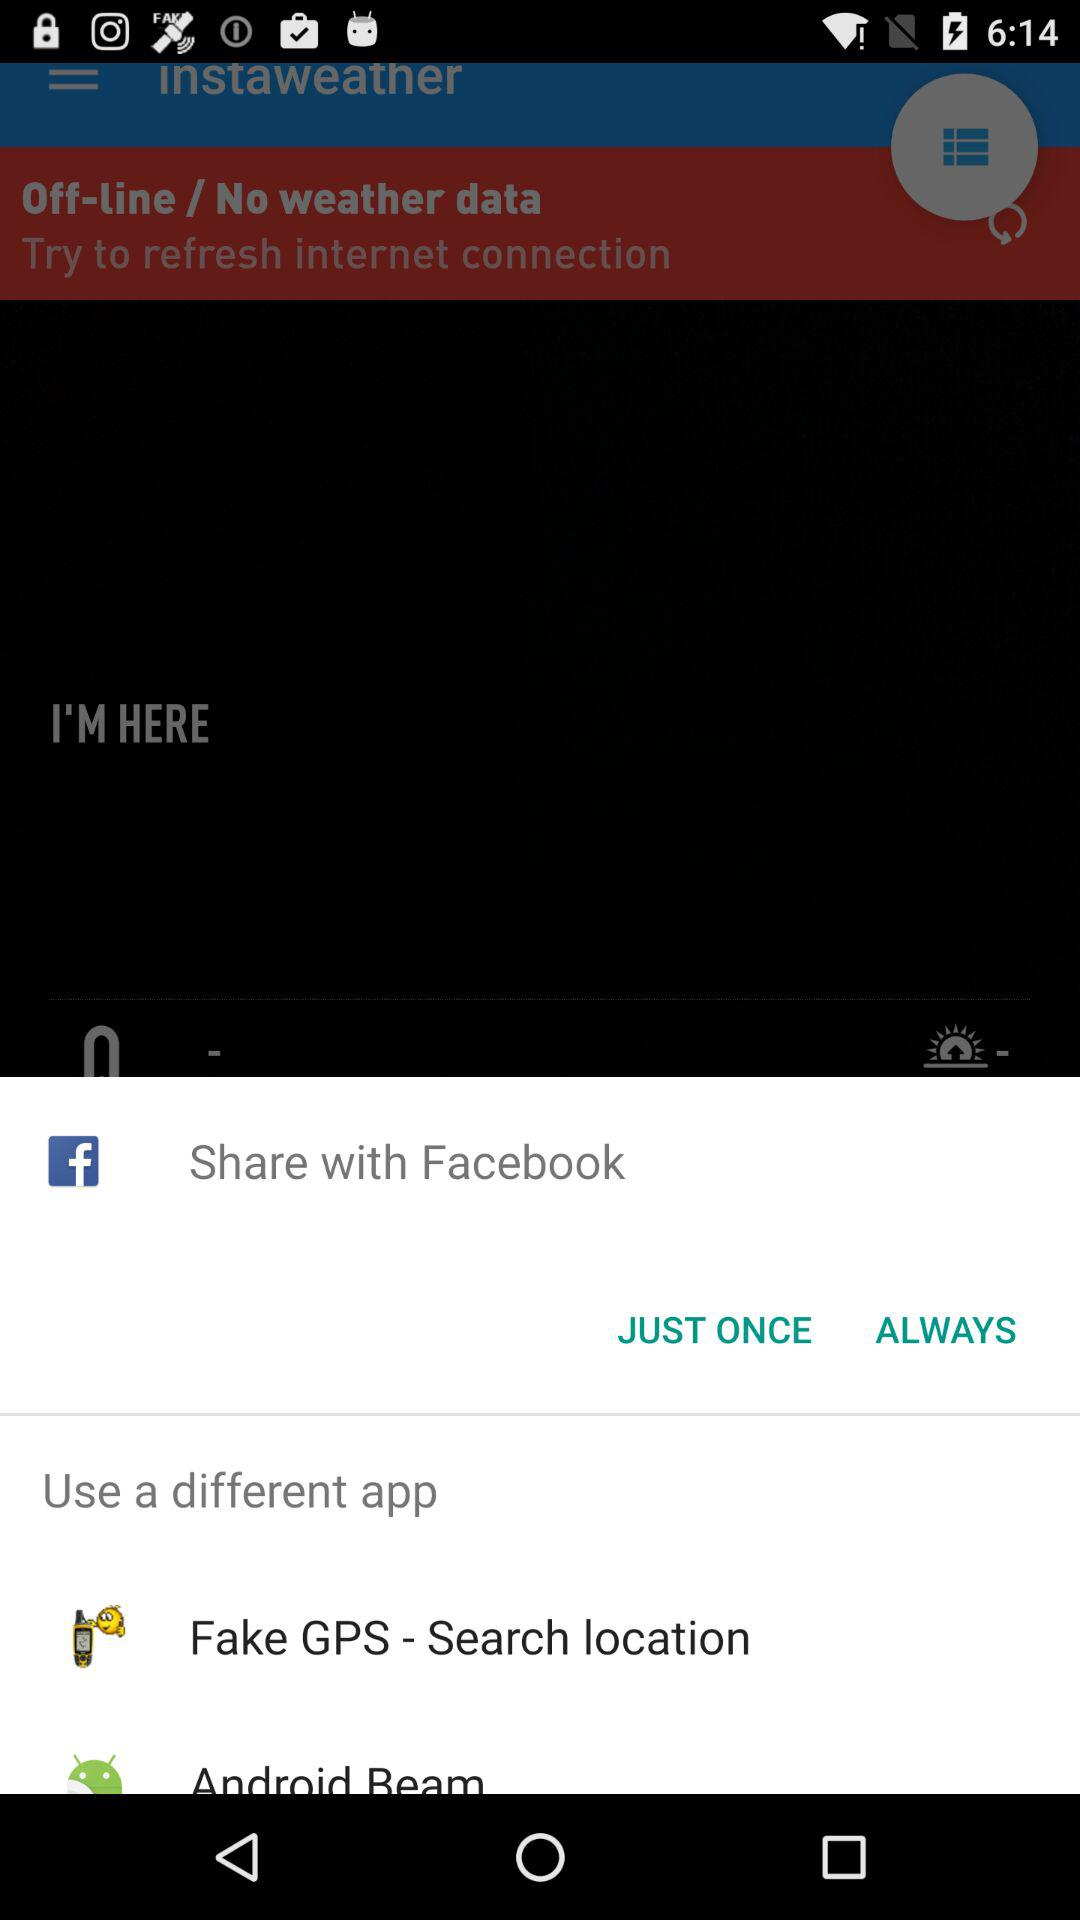How can we share? You can share through "Facebook", "Fake GPS - Search location" and "Android Beam". 